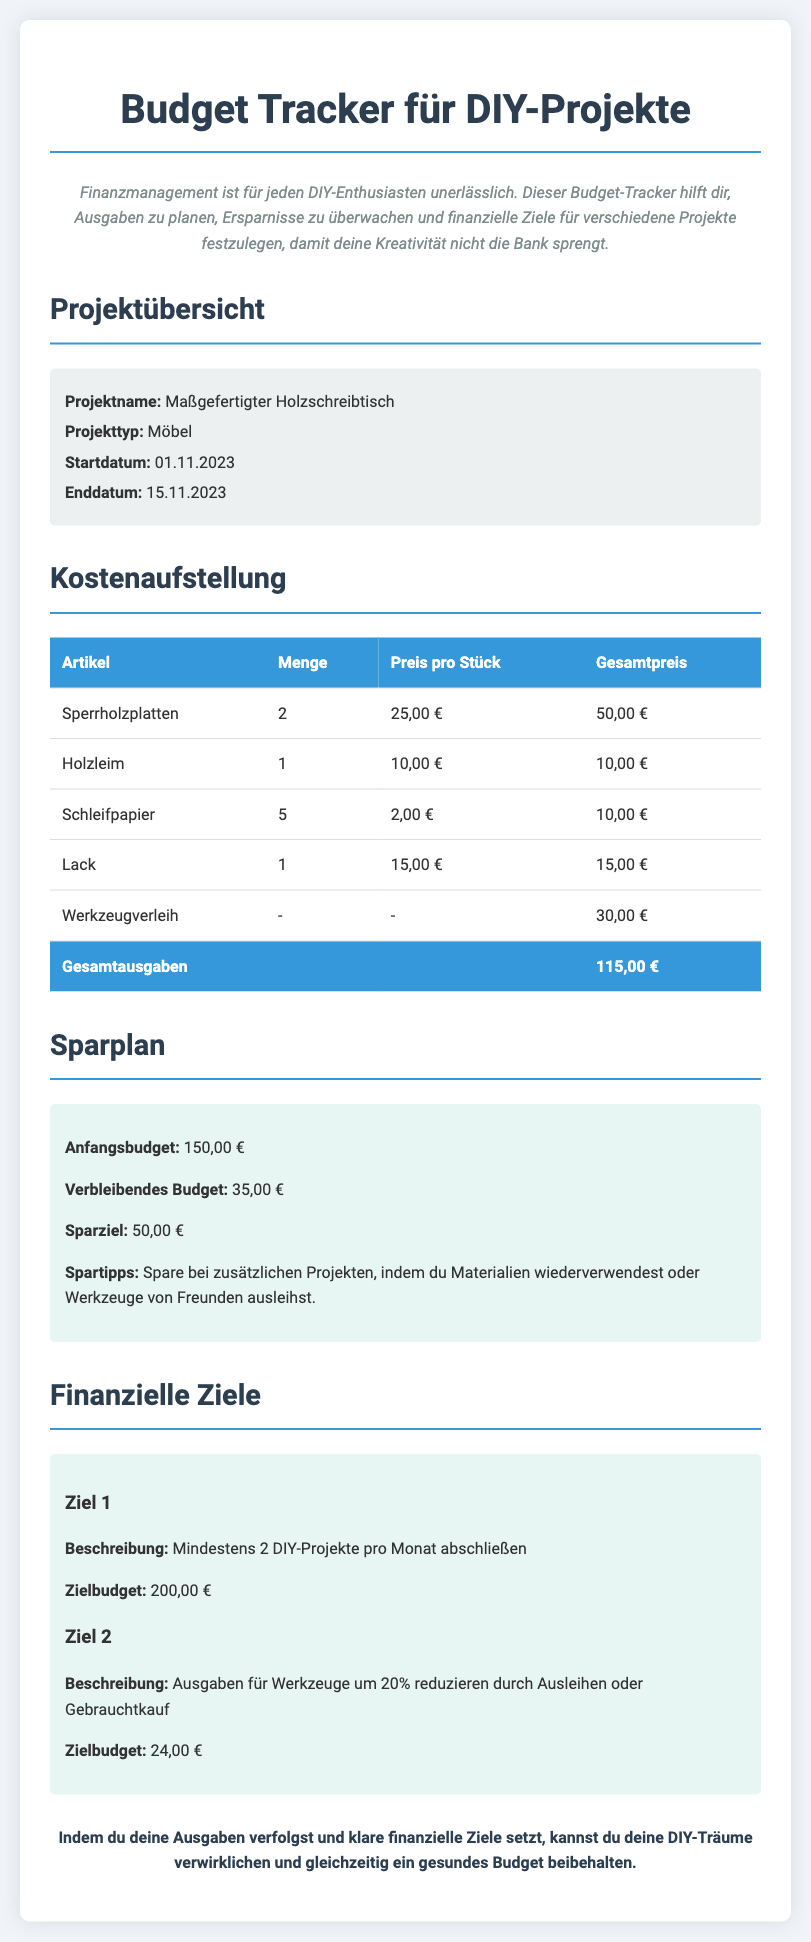Was ist der Projektname? Der Projektname ist im Abschnitt "Projektübersicht" aufgeführt, wo er als "Maßgefertigter Holzschreibtisch" genannt wird.
Answer: Maßgefertigter Holzschreibtisch Wie hoch sind die Gesamtausgaben? Die Gesamtausgaben sind im Abschnitt "Kostenaufstellung" im Fußbereich der Tabelle angegeben.
Answer: 115,00 € Wie viel Geld bleibt nach den Ausgaben? Das verbleibende Budget ist im Abschnitt "Sparplan" angegeben, nachdem die Gesamtausgaben vom Anfangsbudget abgezogen wurden.
Answer: 35,00 € Wann beginnt das Projekt? Das Startdatum ist im Abschnitt "Projektübersicht" angegeben.
Answer: 01.11.2023 Was ist das Zielbudget für Ziel 1? Das Zielbudget für Ziel 1 ist im Abschnitt "Finanzielle Ziele" aufgeführt.
Answer: 200,00 € Welcher Artikel hat den höchsten Einzelpreis? Um dies zu bestimmen, müssen die Einzelpreise in der Kostenaufstellung verglichen werden, wo der Artikel mit dem höchsten Preis "Sperrholzplatten" ist.
Answer: 25,00 € Wie viele DIY-Projekte sollen pro Monat abgeschlossen werden? Dies ist in der Beschreibung von Ziel 1 im Abschnitt "Finanzielle Ziele" zu finden.
Answer: 2 Was ist ein Spartipp? Spartipps sind im Abschnitt "Sparplan" enthalten und einen spezifischen Vorschlag sind, wie man Geld sparen kann, z.B. durch Materialwiederverwendung.
Answer: Materialien wiederverwendet Was ist der Projekttyp? Der Projekttyp ist im Abschnitt "Projektübersicht" angegeben.
Answer: Möbel 